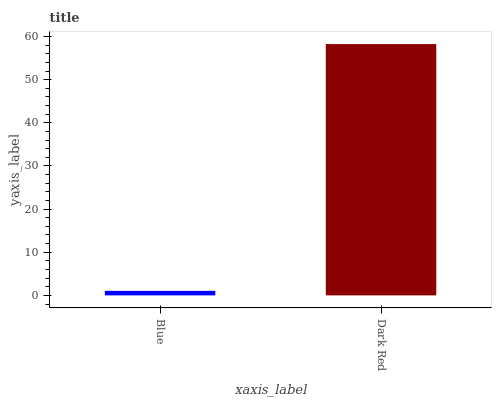Is Blue the minimum?
Answer yes or no. Yes. Is Dark Red the maximum?
Answer yes or no. Yes. Is Dark Red the minimum?
Answer yes or no. No. Is Dark Red greater than Blue?
Answer yes or no. Yes. Is Blue less than Dark Red?
Answer yes or no. Yes. Is Blue greater than Dark Red?
Answer yes or no. No. Is Dark Red less than Blue?
Answer yes or no. No. Is Dark Red the high median?
Answer yes or no. Yes. Is Blue the low median?
Answer yes or no. Yes. Is Blue the high median?
Answer yes or no. No. Is Dark Red the low median?
Answer yes or no. No. 